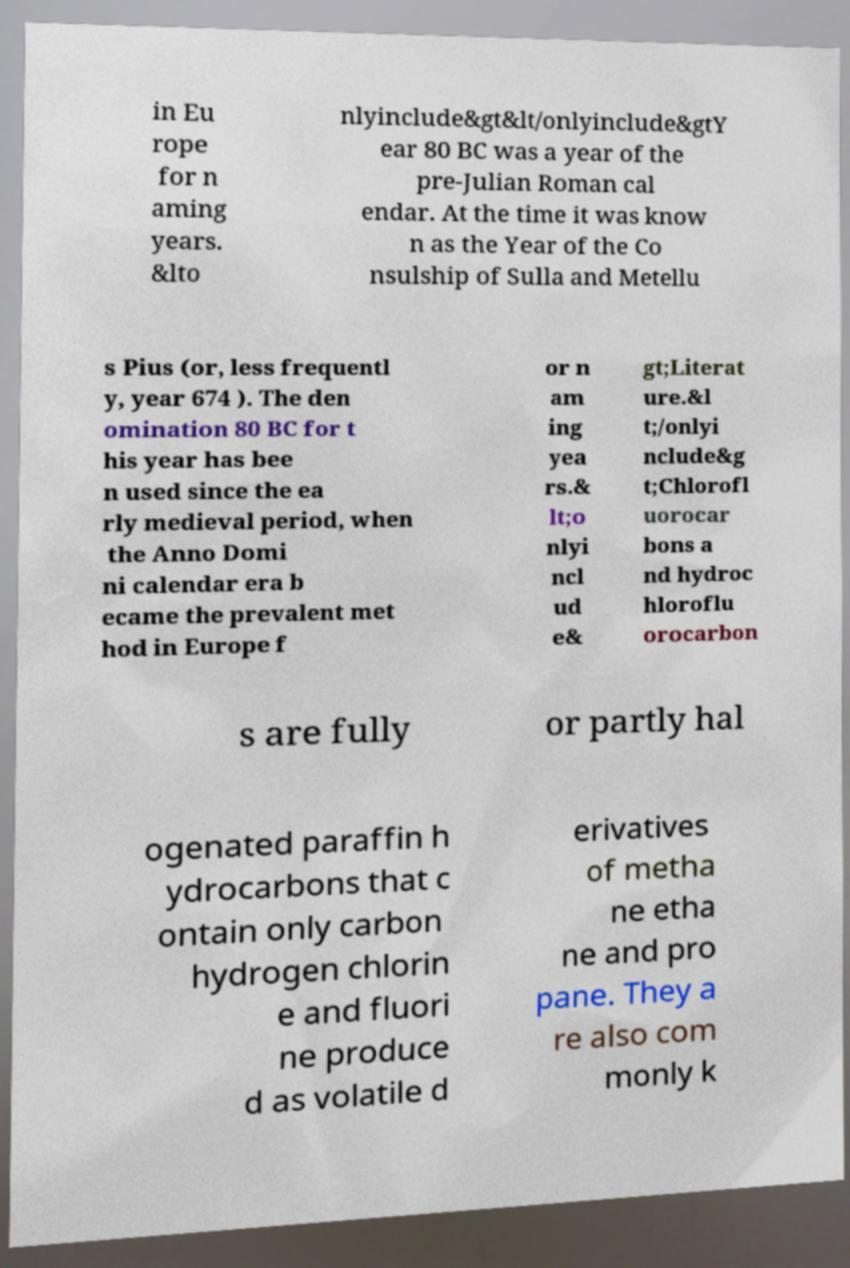Could you extract and type out the text from this image? in Eu rope for n aming years. &lto nlyinclude&gt&lt/onlyinclude&gtY ear 80 BC was a year of the pre-Julian Roman cal endar. At the time it was know n as the Year of the Co nsulship of Sulla and Metellu s Pius (or, less frequentl y, year 674 ). The den omination 80 BC for t his year has bee n used since the ea rly medieval period, when the Anno Domi ni calendar era b ecame the prevalent met hod in Europe f or n am ing yea rs.& lt;o nlyi ncl ud e& gt;Literat ure.&l t;/onlyi nclude&g t;Chlorofl uorocar bons a nd hydroc hloroflu orocarbon s are fully or partly hal ogenated paraffin h ydrocarbons that c ontain only carbon hydrogen chlorin e and fluori ne produce d as volatile d erivatives of metha ne etha ne and pro pane. They a re also com monly k 